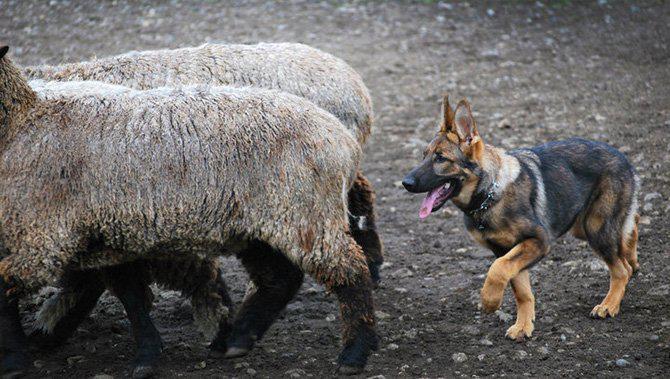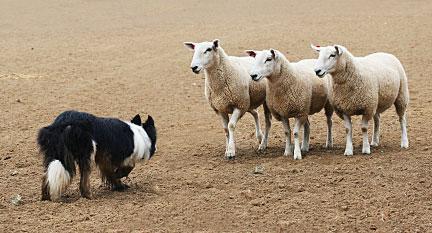The first image is the image on the left, the second image is the image on the right. Evaluate the accuracy of this statement regarding the images: "Left and right images each show a black-and-white dog in front of multiple standing cattle.". Is it true? Answer yes or no. No. The first image is the image on the left, the second image is the image on the right. Given the left and right images, does the statement "One image contains a sheep dog herding three or more sheep." hold true? Answer yes or no. Yes. 